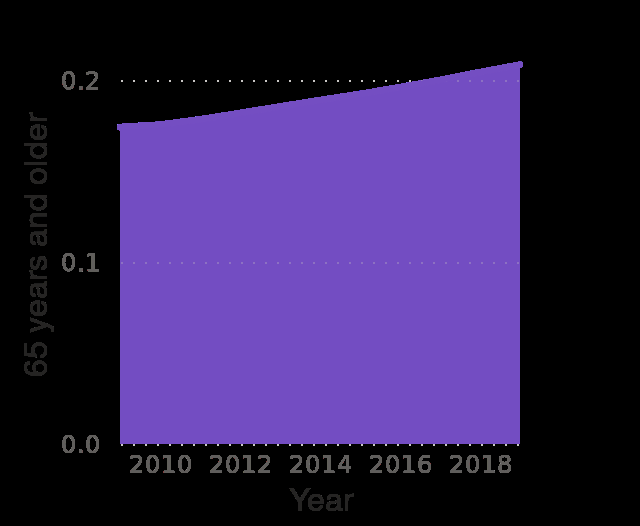<image>
please summary the statistics and relations of the chart The number of 65 years and older was fairly stable for the first half of 2010. The number of 65 years and older has increased steadily since around the middle of 2010. please describe the details of the chart This is a area diagram labeled Croatia : Age structure from 2009 to 2019. The y-axis shows 65 years and older while the x-axis shows Year. 